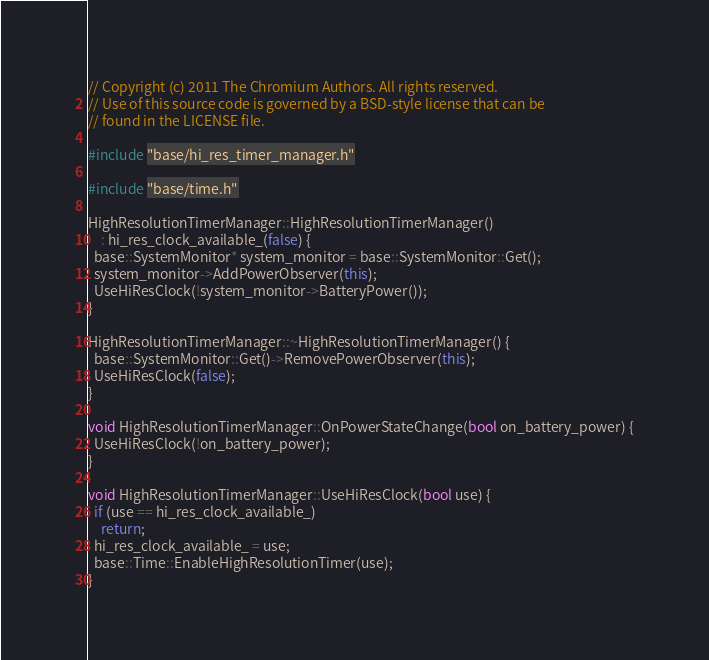<code> <loc_0><loc_0><loc_500><loc_500><_C++_>// Copyright (c) 2011 The Chromium Authors. All rights reserved.
// Use of this source code is governed by a BSD-style license that can be
// found in the LICENSE file.

#include "base/hi_res_timer_manager.h"

#include "base/time.h"

HighResolutionTimerManager::HighResolutionTimerManager()
    : hi_res_clock_available_(false) {
  base::SystemMonitor* system_monitor = base::SystemMonitor::Get();
  system_monitor->AddPowerObserver(this);
  UseHiResClock(!system_monitor->BatteryPower());
}

HighResolutionTimerManager::~HighResolutionTimerManager() {
  base::SystemMonitor::Get()->RemovePowerObserver(this);
  UseHiResClock(false);
}

void HighResolutionTimerManager::OnPowerStateChange(bool on_battery_power) {
  UseHiResClock(!on_battery_power);
}

void HighResolutionTimerManager::UseHiResClock(bool use) {
  if (use == hi_res_clock_available_)
    return;
  hi_res_clock_available_ = use;
  base::Time::EnableHighResolutionTimer(use);
}
</code> 